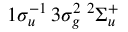Convert formula to latex. <formula><loc_0><loc_0><loc_500><loc_500>1 \sigma _ { u } ^ { - 1 } \, 3 \sigma _ { g } ^ { 2 } \, { ^ { 2 } } \Sigma _ { u } ^ { + }</formula> 